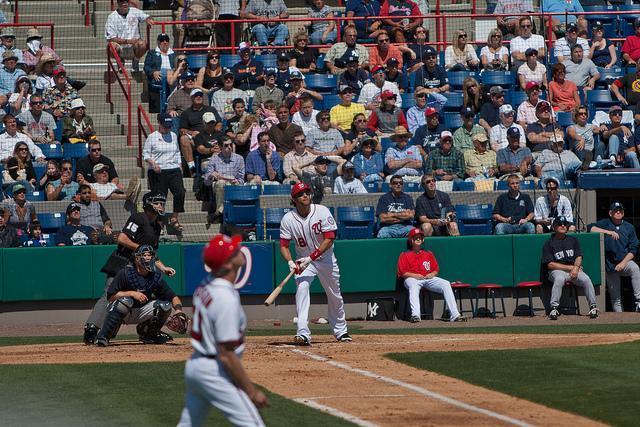How many players in blue and white?
Give a very brief answer. 2. How many people are there?
Give a very brief answer. 7. 